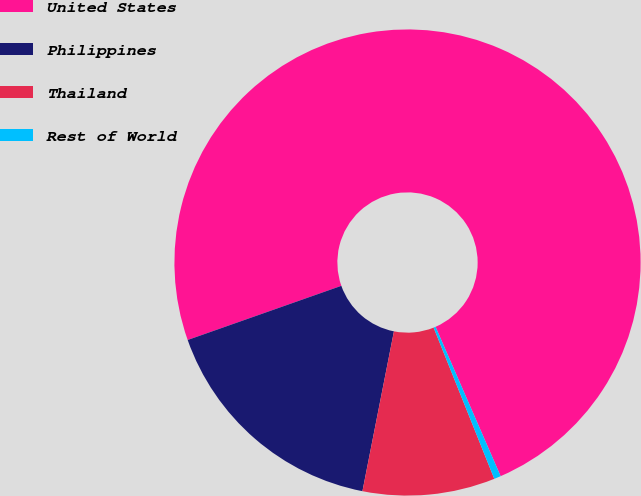<chart> <loc_0><loc_0><loc_500><loc_500><pie_chart><fcel>United States<fcel>Philippines<fcel>Thailand<fcel>Rest of World<nl><fcel>73.85%<fcel>16.51%<fcel>9.17%<fcel>0.47%<nl></chart> 